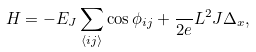Convert formula to latex. <formula><loc_0><loc_0><loc_500><loc_500>H = - E _ { J } \sum _ { \langle i j \rangle } \cos \phi _ { i j } + \frac { } { 2 e } L ^ { 2 } J \Delta _ { x } ,</formula> 